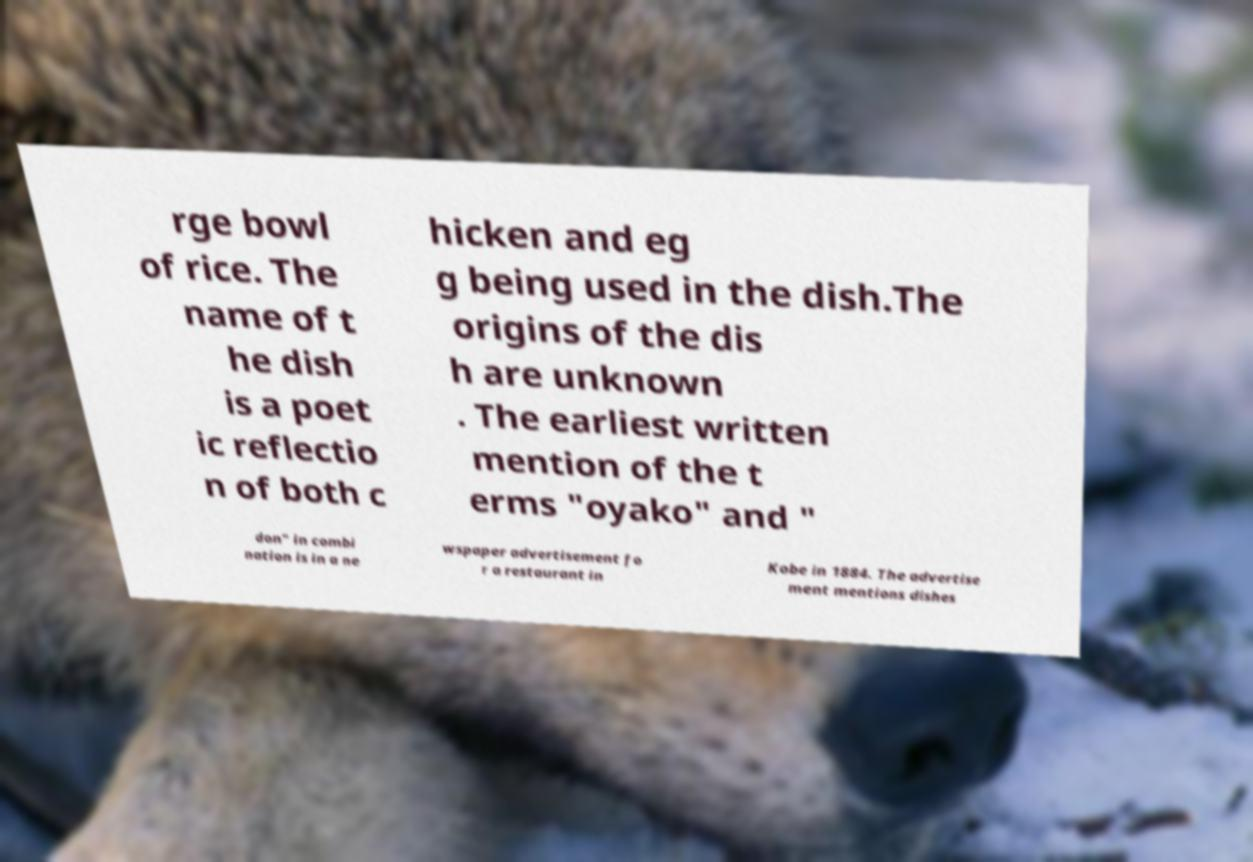Can you accurately transcribe the text from the provided image for me? rge bowl of rice. The name of t he dish is a poet ic reflectio n of both c hicken and eg g being used in the dish.The origins of the dis h are unknown . The earliest written mention of the t erms "oyako" and " don" in combi nation is in a ne wspaper advertisement fo r a restaurant in Kobe in 1884. The advertise ment mentions dishes 